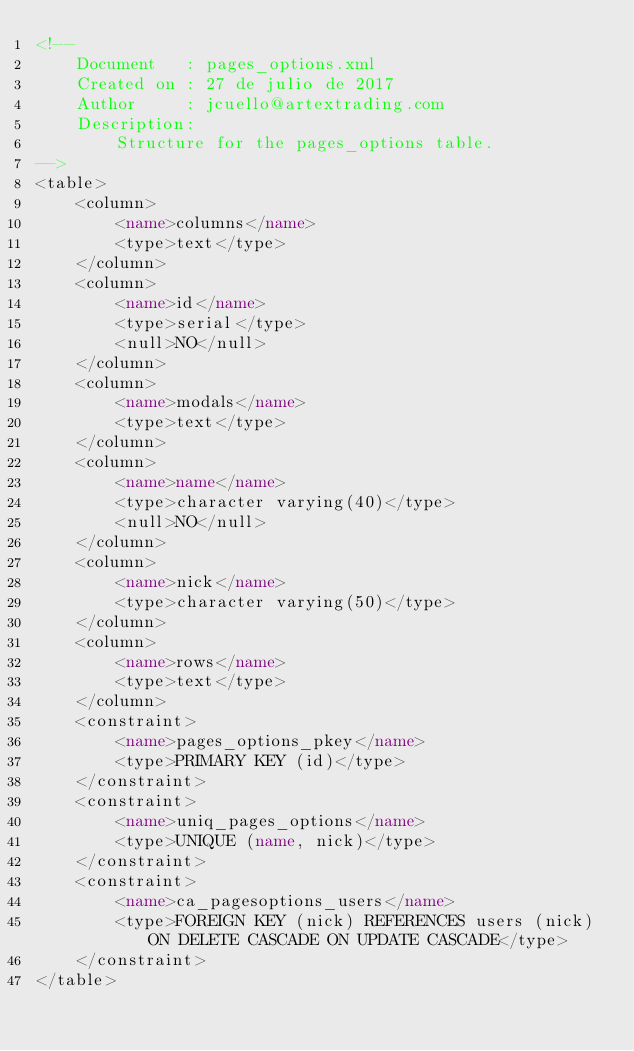<code> <loc_0><loc_0><loc_500><loc_500><_XML_><!--
    Document   : pages_options.xml
    Created on : 27 de julio de 2017
    Author     : jcuello@artextrading.com
    Description:
        Structure for the pages_options table.
-->
<table>
    <column>
        <name>columns</name>
        <type>text</type>
    </column>
    <column>
        <name>id</name>
        <type>serial</type>
        <null>NO</null>
    </column>
    <column>
        <name>modals</name>
        <type>text</type>
    </column>
    <column>
        <name>name</name>
        <type>character varying(40)</type>
        <null>NO</null>
    </column>
    <column>
        <name>nick</name>
        <type>character varying(50)</type>
    </column>
    <column>
        <name>rows</name>
        <type>text</type>
    </column>
    <constraint>
        <name>pages_options_pkey</name>
        <type>PRIMARY KEY (id)</type>
    </constraint>
    <constraint>
        <name>uniq_pages_options</name>
        <type>UNIQUE (name, nick)</type>
    </constraint>
    <constraint>
        <name>ca_pagesoptions_users</name>
        <type>FOREIGN KEY (nick) REFERENCES users (nick) ON DELETE CASCADE ON UPDATE CASCADE</type>
    </constraint>
</table></code> 